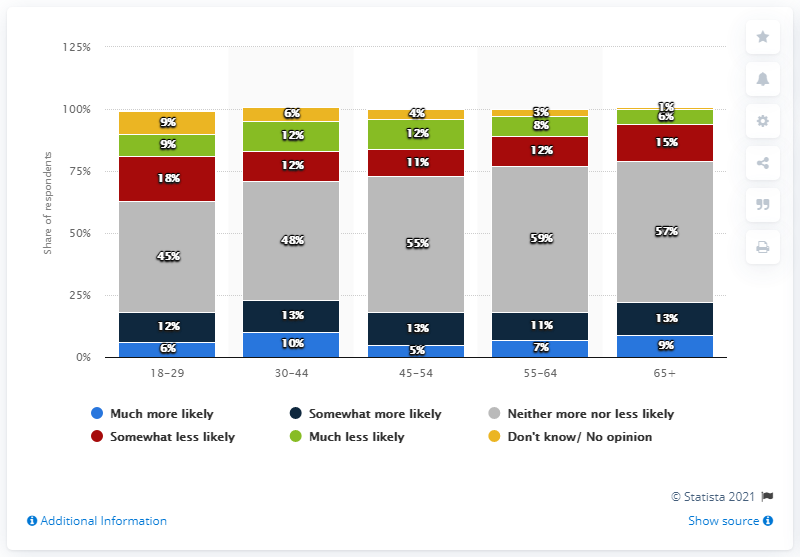Highlight a few significant elements in this photo. The mode of the group of numbers 18-29 is 9. The average of all "Neither more nor less likely" ratings is 52.8. 